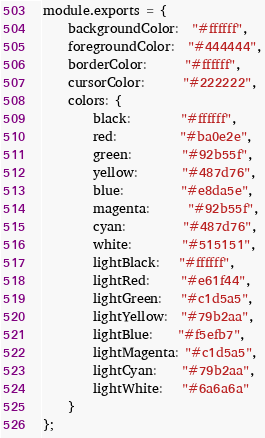<code> <loc_0><loc_0><loc_500><loc_500><_JavaScript_>module.exports = {
    backgroundColor:  "#ffffff",
    foregroundColor:  "#444444",
    borderColor:      "#ffffff",
    cursorColor:      "#222222",
    colors: {
        black:        "#ffffff",
        red:          "#ba0e2e",
        green:        "#92b55f",
        yellow:       "#487d76",
        blue:         "#e8da5e",
        magenta:      "#92b55f",
        cyan:         "#487d76",
        white:        "#515151",
        lightBlack:   "#ffffff",
        lightRed:     "#e61f44",
        lightGreen:   "#c1d5a5",
        lightYellow:  "#79b2aa",
        lightBlue:    "#f5efb7",
        lightMagenta: "#c1d5a5",
        lightCyan:    "#79b2aa",
        lightWhite:   "#6a6a6a"
    }
};</code> 